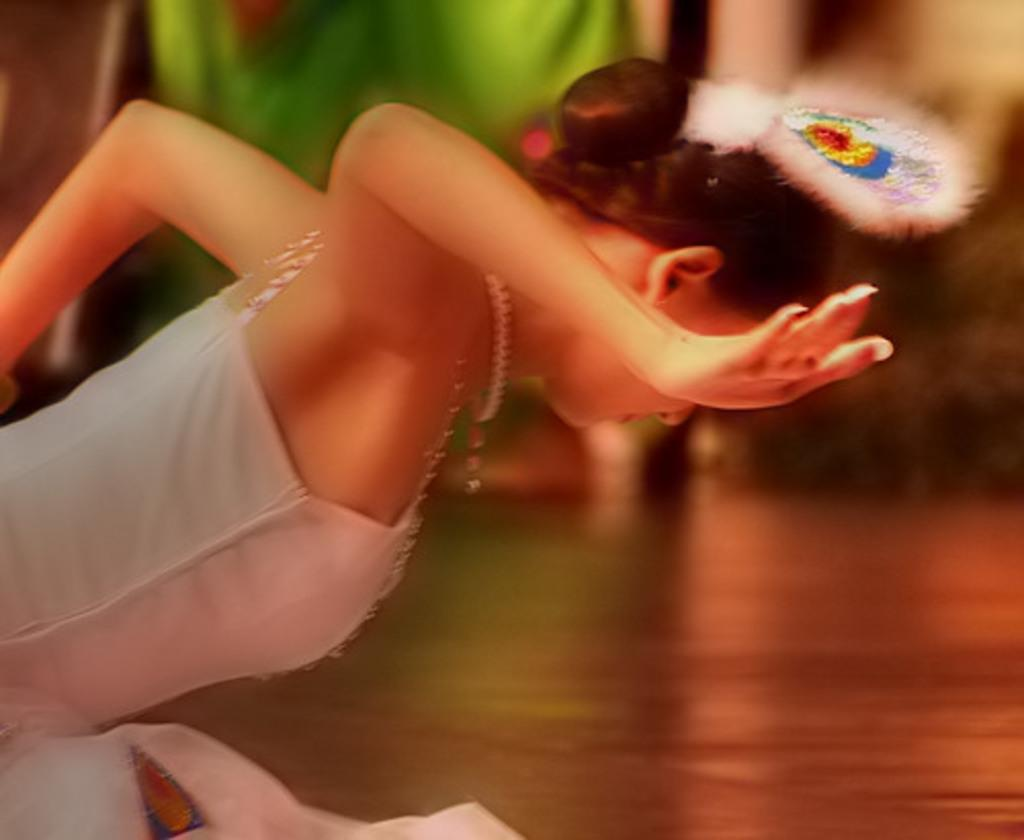Who is the main subject in the image? There is a woman in the image. Where is the woman located in the image? The woman is in the middle of the image. What is the woman wearing in the image? The woman is wearing a white dress. What type of quartz can be seen in the woman's hand in the image? There is no quartz present in the image, and the woman's hands are not visible. 